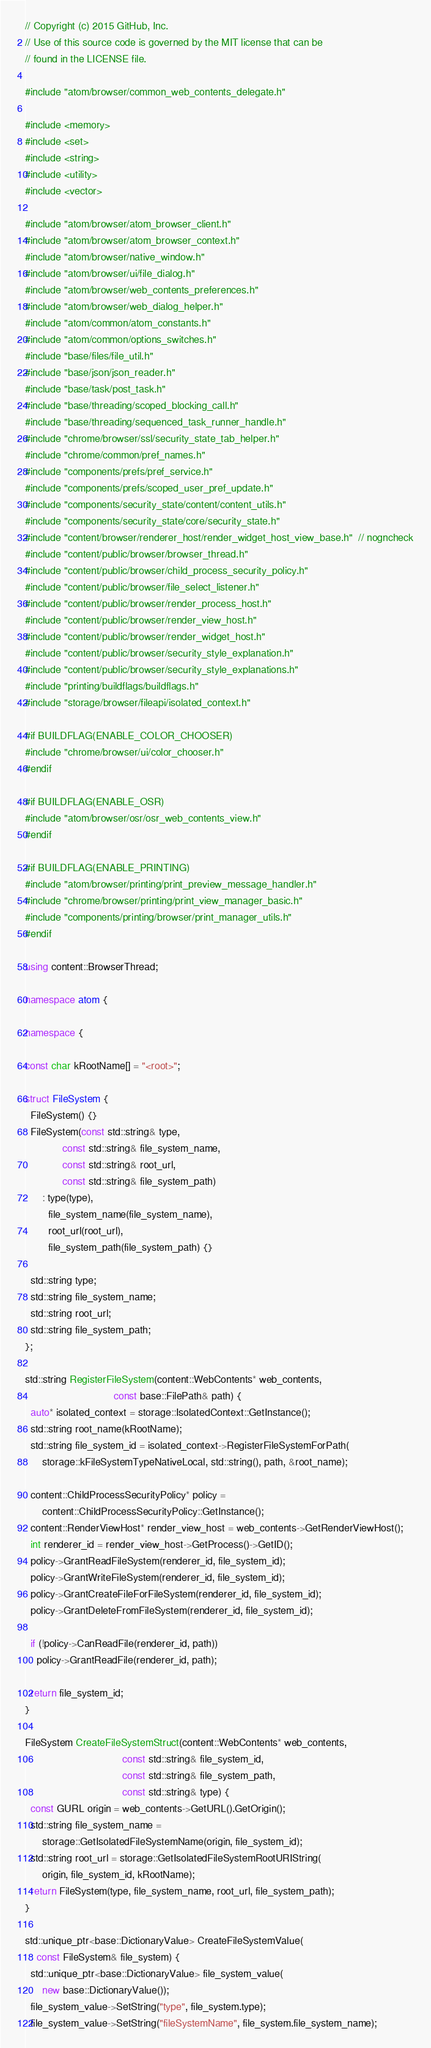<code> <loc_0><loc_0><loc_500><loc_500><_C++_>// Copyright (c) 2015 GitHub, Inc.
// Use of this source code is governed by the MIT license that can be
// found in the LICENSE file.

#include "atom/browser/common_web_contents_delegate.h"

#include <memory>
#include <set>
#include <string>
#include <utility>
#include <vector>

#include "atom/browser/atom_browser_client.h"
#include "atom/browser/atom_browser_context.h"
#include "atom/browser/native_window.h"
#include "atom/browser/ui/file_dialog.h"
#include "atom/browser/web_contents_preferences.h"
#include "atom/browser/web_dialog_helper.h"
#include "atom/common/atom_constants.h"
#include "atom/common/options_switches.h"
#include "base/files/file_util.h"
#include "base/json/json_reader.h"
#include "base/task/post_task.h"
#include "base/threading/scoped_blocking_call.h"
#include "base/threading/sequenced_task_runner_handle.h"
#include "chrome/browser/ssl/security_state_tab_helper.h"
#include "chrome/common/pref_names.h"
#include "components/prefs/pref_service.h"
#include "components/prefs/scoped_user_pref_update.h"
#include "components/security_state/content/content_utils.h"
#include "components/security_state/core/security_state.h"
#include "content/browser/renderer_host/render_widget_host_view_base.h"  // nogncheck
#include "content/public/browser/browser_thread.h"
#include "content/public/browser/child_process_security_policy.h"
#include "content/public/browser/file_select_listener.h"
#include "content/public/browser/render_process_host.h"
#include "content/public/browser/render_view_host.h"
#include "content/public/browser/render_widget_host.h"
#include "content/public/browser/security_style_explanation.h"
#include "content/public/browser/security_style_explanations.h"
#include "printing/buildflags/buildflags.h"
#include "storage/browser/fileapi/isolated_context.h"

#if BUILDFLAG(ENABLE_COLOR_CHOOSER)
#include "chrome/browser/ui/color_chooser.h"
#endif

#if BUILDFLAG(ENABLE_OSR)
#include "atom/browser/osr/osr_web_contents_view.h"
#endif

#if BUILDFLAG(ENABLE_PRINTING)
#include "atom/browser/printing/print_preview_message_handler.h"
#include "chrome/browser/printing/print_view_manager_basic.h"
#include "components/printing/browser/print_manager_utils.h"
#endif

using content::BrowserThread;

namespace atom {

namespace {

const char kRootName[] = "<root>";

struct FileSystem {
  FileSystem() {}
  FileSystem(const std::string& type,
             const std::string& file_system_name,
             const std::string& root_url,
             const std::string& file_system_path)
      : type(type),
        file_system_name(file_system_name),
        root_url(root_url),
        file_system_path(file_system_path) {}

  std::string type;
  std::string file_system_name;
  std::string root_url;
  std::string file_system_path;
};

std::string RegisterFileSystem(content::WebContents* web_contents,
                               const base::FilePath& path) {
  auto* isolated_context = storage::IsolatedContext::GetInstance();
  std::string root_name(kRootName);
  std::string file_system_id = isolated_context->RegisterFileSystemForPath(
      storage::kFileSystemTypeNativeLocal, std::string(), path, &root_name);

  content::ChildProcessSecurityPolicy* policy =
      content::ChildProcessSecurityPolicy::GetInstance();
  content::RenderViewHost* render_view_host = web_contents->GetRenderViewHost();
  int renderer_id = render_view_host->GetProcess()->GetID();
  policy->GrantReadFileSystem(renderer_id, file_system_id);
  policy->GrantWriteFileSystem(renderer_id, file_system_id);
  policy->GrantCreateFileForFileSystem(renderer_id, file_system_id);
  policy->GrantDeleteFromFileSystem(renderer_id, file_system_id);

  if (!policy->CanReadFile(renderer_id, path))
    policy->GrantReadFile(renderer_id, path);

  return file_system_id;
}

FileSystem CreateFileSystemStruct(content::WebContents* web_contents,
                                  const std::string& file_system_id,
                                  const std::string& file_system_path,
                                  const std::string& type) {
  const GURL origin = web_contents->GetURL().GetOrigin();
  std::string file_system_name =
      storage::GetIsolatedFileSystemName(origin, file_system_id);
  std::string root_url = storage::GetIsolatedFileSystemRootURIString(
      origin, file_system_id, kRootName);
  return FileSystem(type, file_system_name, root_url, file_system_path);
}

std::unique_ptr<base::DictionaryValue> CreateFileSystemValue(
    const FileSystem& file_system) {
  std::unique_ptr<base::DictionaryValue> file_system_value(
      new base::DictionaryValue());
  file_system_value->SetString("type", file_system.type);
  file_system_value->SetString("fileSystemName", file_system.file_system_name);</code> 